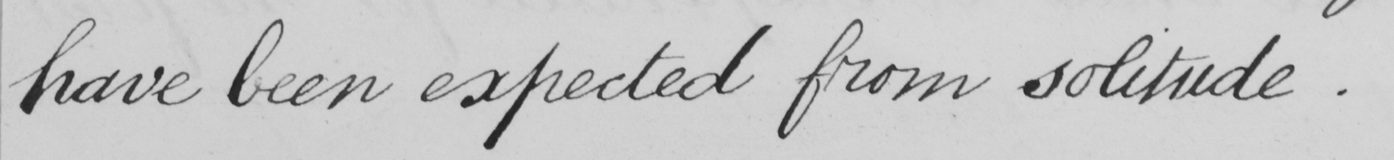Can you read and transcribe this handwriting? have been expected from solitude. 